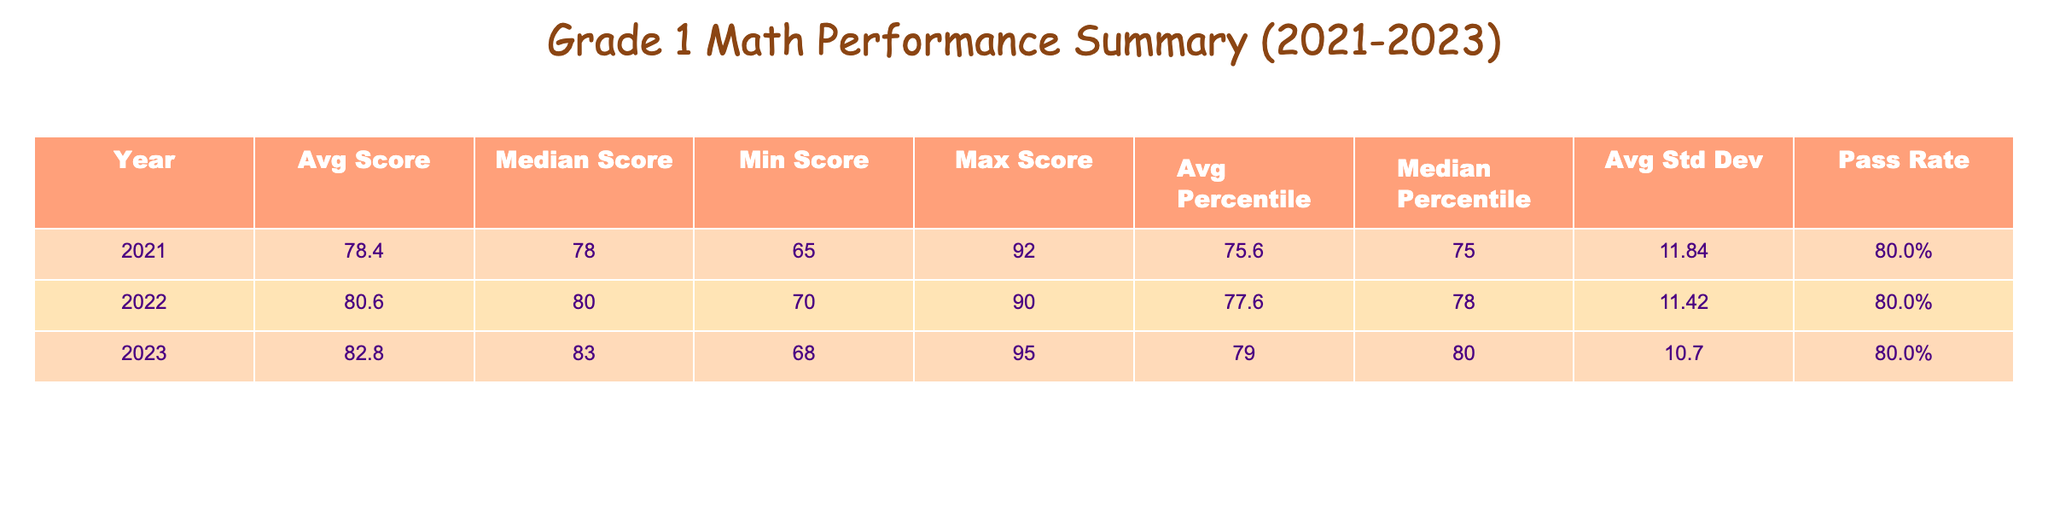What was the highest math score recorded in 2022? The maximum score for 2022 can be found in the table under the 'Max Score' column for the year 2022. For that year, the highest score is 90 from Greenfield Academy.
Answer: 90 What was the average percentile rank of students in 2021? To find the average percentile rank for 2021, we take the scores from that year (90, 75, 95, 50, 68) and calculate their average: (90 + 75 + 95 + 50 + 68) / 5 = 75.6, rounded to two decimal places gives us 75.6.
Answer: 75.6 Did more than 70% of students pass in 2023? In 2023, four students passed and one failed. To calculate the pass rate, divide the number of passes by the total number of students: 4 passes out of 5 students is (4 / 5) * 100 = 80%. This confirms that more than 70% passed.
Answer: Yes Which school had the lowest average score over the three years? We will look at each school's average score across the years. Maple Grove averages (85+88+91) / 3 = 88, Sunrise averages (78+80+83) / 3 = 80.33, Greenfield averages (92+90+95) / 3 = 92.33, Woodland averages (65+70+68) / 3 = 67.67, and Bright Futures averages (72+75+77) / 3 = 74.67. The lowest average score is Woodland Heights at 67.67.
Answer: Woodland Heights What is the standard deviation of math scores in 2021? The standard deviation is reported directly in the table under the 'Standard Deviation' column for 2021. The average standard deviation for that year is 12.7.
Answer: 12.7 